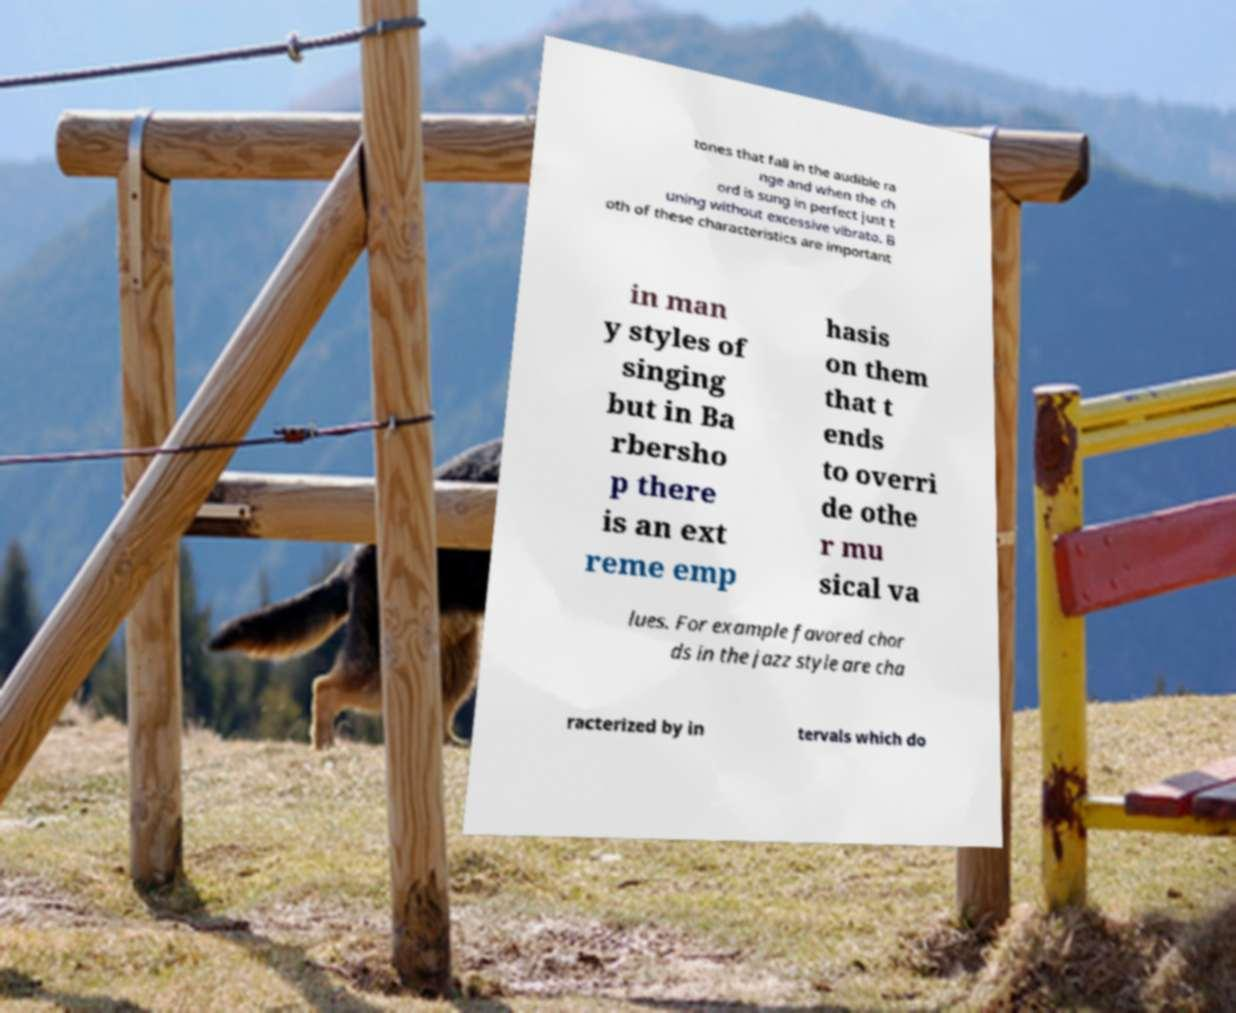Can you read and provide the text displayed in the image?This photo seems to have some interesting text. Can you extract and type it out for me? tones that fall in the audible ra nge and when the ch ord is sung in perfect just t uning without excessive vibrato. B oth of these characteristics are important in man y styles of singing but in Ba rbersho p there is an ext reme emp hasis on them that t ends to overri de othe r mu sical va lues. For example favored chor ds in the jazz style are cha racterized by in tervals which do 